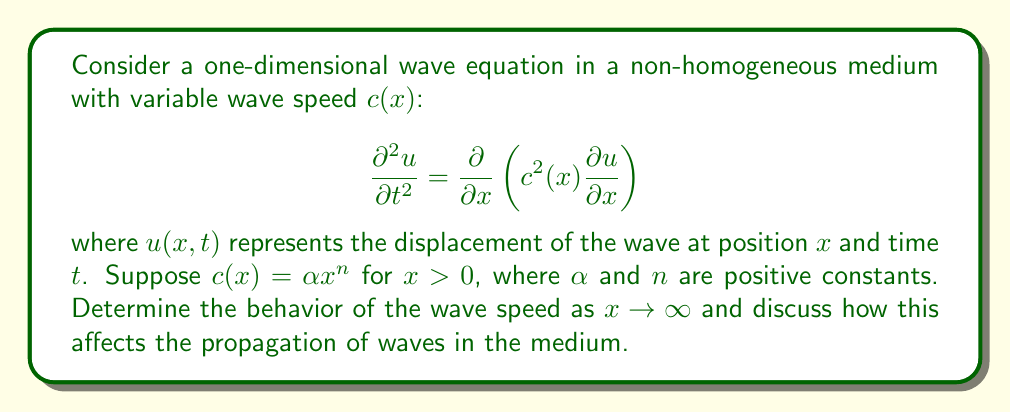Help me with this question. To analyze the behavior of solutions to this wave equation, we need to follow these steps:

1) First, let's examine the wave speed function:
   $c(x) = \alpha x^n$, where $\alpha > 0$ and $n > 0$

2) To determine the behavior as $x \to \infty$, we take the limit:
   $$\lim_{x \to \infty} c(x) = \lim_{x \to \infty} \alpha x^n = \infty$$

3) This means that as $x$ increases, the wave speed increases without bound.

4) In a medium with increasing wave speed:
   a) Waves will accelerate as they propagate to the right (increasing $x$).
   b) The wavelength will increase as the wave moves to the right.
   c) The amplitude of the wave will decrease to conserve energy.

5) The equation can be rewritten as:
   $$\frac{\partial^2 u}{\partial t^2} = \alpha^2 x^{2n} \frac{\partial^2 u}{\partial x^2} + 2n\alpha^2 x^{2n-1} \frac{\partial u}{\partial x}$$

6) This equation has a singular point at $x = 0$ if $n > \frac{1}{2}$, which may lead to unique behavior near the origin.

7) For large $x$, the dominant term will be $\alpha^2 x^{2n} \frac{\partial^2 u}{\partial x^2}$, suggesting that the wave behavior far from the origin will be primarily influenced by the rapidly increasing wave speed.

8) The increasing wave speed implies that any localized disturbance will spread out more rapidly as it propagates, leading to dispersion of the wave packet.

9) In the context of energy propagation, the increasing wave speed means that energy will be transported more quickly at larger distances from the origin.
Answer: As $x \to \infty$, $c(x) \to \infty$. Waves accelerate, wavelengths increase, and amplitudes decrease as they propagate. The medium exhibits strong dispersion and rapid energy transport at large distances. 